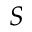Convert formula to latex. <formula><loc_0><loc_0><loc_500><loc_500>S</formula> 